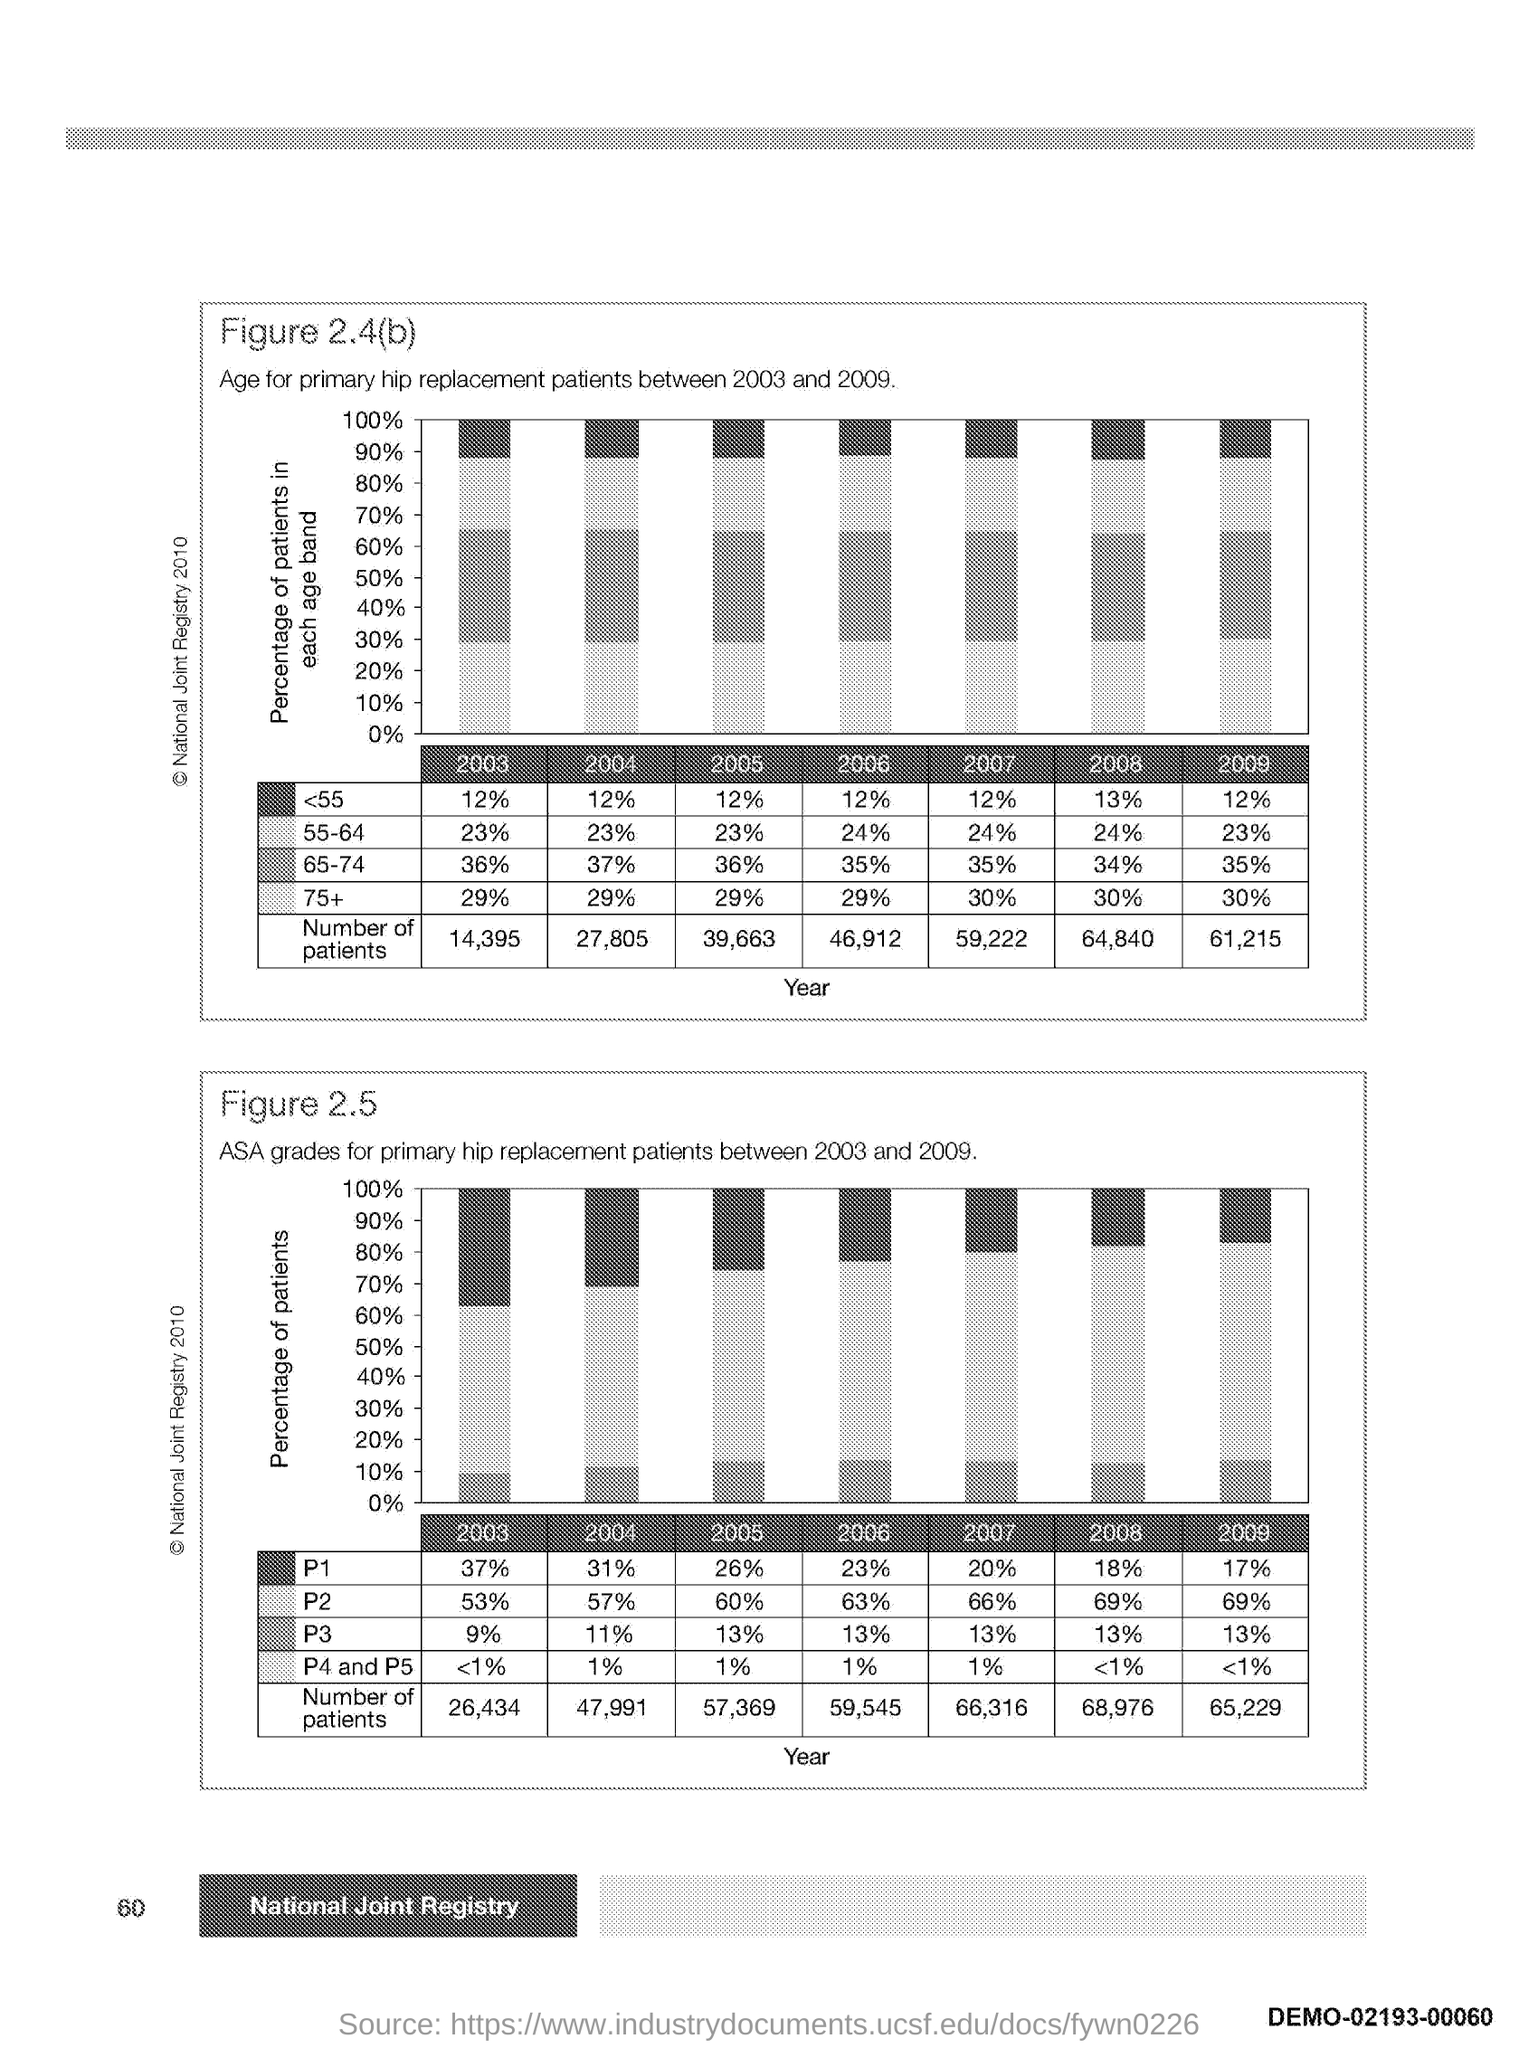Draw attention to some important aspects in this diagram. The second graph plotted the percentage of patients as the y-axis, which represents the percentage of patients who experienced a particular adverse event. The first graph plotted the year on the x-axis. 